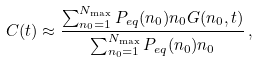Convert formula to latex. <formula><loc_0><loc_0><loc_500><loc_500>C ( t ) \approx \frac { \sum _ { n _ { 0 } = 1 } ^ { N _ { \max } } P _ { e q } ( n _ { 0 } ) n _ { 0 } G ( n _ { 0 } , t ) } { \sum _ { n _ { 0 } = 1 } ^ { N _ { \max } } P _ { e q } ( n _ { 0 } ) n _ { 0 } } \, ,</formula> 